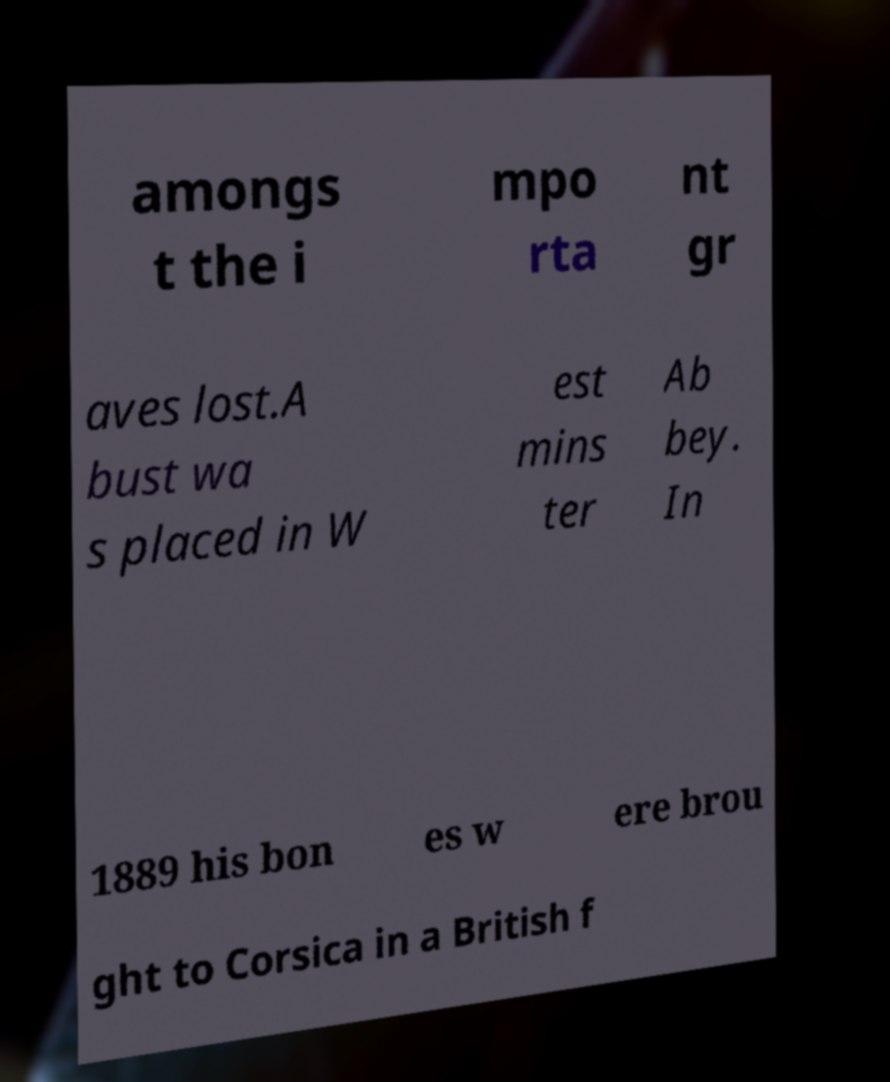Please read and relay the text visible in this image. What does it say? amongs t the i mpo rta nt gr aves lost.A bust wa s placed in W est mins ter Ab bey. In 1889 his bon es w ere brou ght to Corsica in a British f 